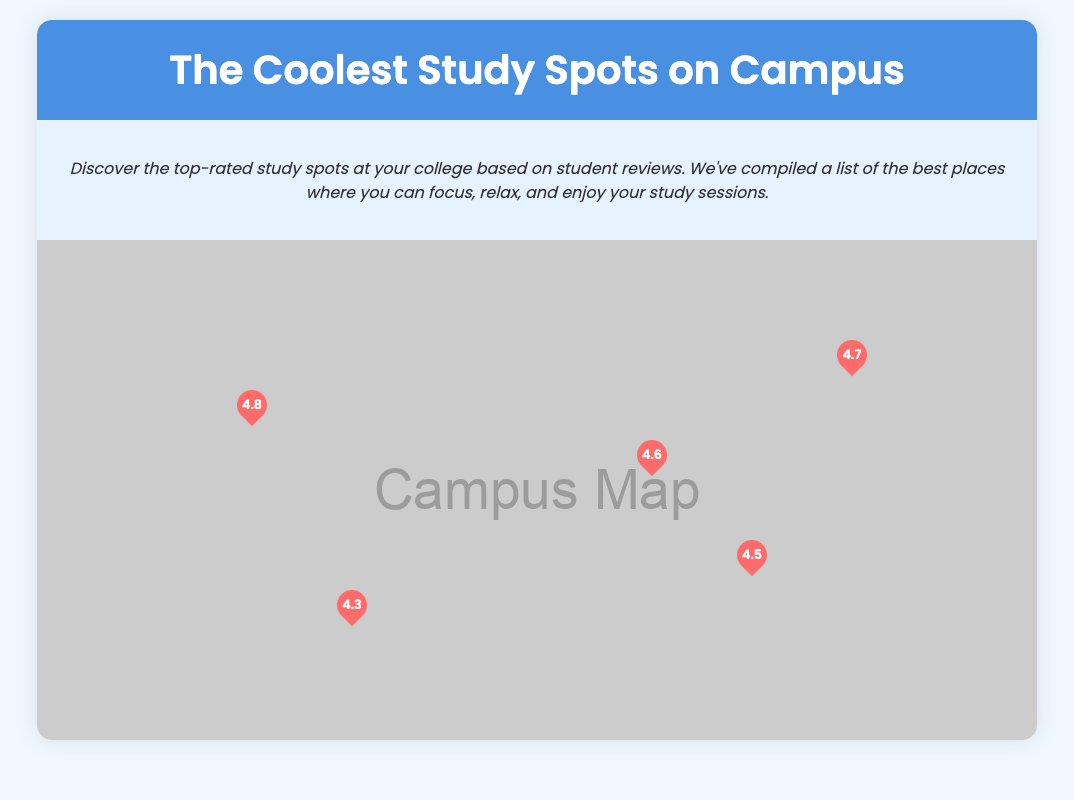What is the highest-rated study spot? The highest-rated study spot is indicated as having a rating of 4.8 in the document.
Answer: Central Library What amenity is available at Greenlake Park? Greenlake Park lists "Outdoor benches" as one of its amenities.
Answer: Outdoor benches Which study spot offers 24/7 access? The document specifies that the Engineering Building Study Hall provides 24/7 access.
Answer: Engineering Building Study Hall How many reviews are listed for Café Aroma? The document displays two reviews for Café Aroma.
Answer: 2 What is the rating of the Student Union Lounge? The rating of the Student Union Lounge can be found in the document and is listed there.
Answer: 4.6 Which location is highlighted as having a café on the ground floor? The Central Library has a café on the ground floor, as noted in the amenities section.
Answer: Central Library What is the description of the study spot rated 4.5? Café Aroma is described in the document as having a rating of 4.5, along with its amenities listed.
Answer: Café Aroma Which spot is noted for best late-night study sessions? The Engineering Building Study Hall is highlighted for being the best place for late-night study sessions.
Answer: Engineering Building Study Hall 